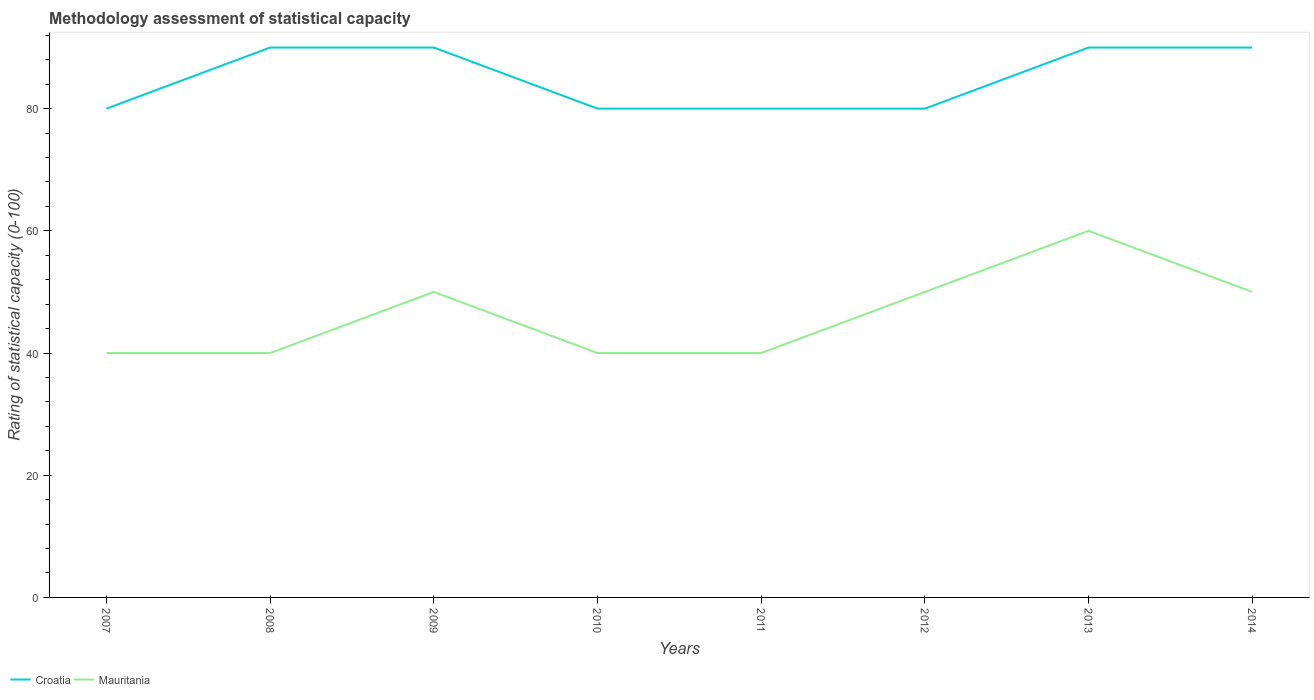Does the line corresponding to Mauritania intersect with the line corresponding to Croatia?
Make the answer very short. No. Is the number of lines equal to the number of legend labels?
Offer a very short reply. Yes. Across all years, what is the maximum rating of statistical capacity in Croatia?
Ensure brevity in your answer.  80. What is the total rating of statistical capacity in Mauritania in the graph?
Make the answer very short. -10. What is the difference between the highest and the second highest rating of statistical capacity in Croatia?
Provide a short and direct response. 10. How many lines are there?
Your answer should be compact. 2. What is the difference between two consecutive major ticks on the Y-axis?
Offer a very short reply. 20. Does the graph contain grids?
Offer a terse response. No. Where does the legend appear in the graph?
Your response must be concise. Bottom left. What is the title of the graph?
Provide a succinct answer. Methodology assessment of statistical capacity. Does "Belgium" appear as one of the legend labels in the graph?
Offer a terse response. No. What is the label or title of the Y-axis?
Your answer should be compact. Rating of statistical capacity (0-100). What is the Rating of statistical capacity (0-100) of Croatia in 2007?
Offer a very short reply. 80. What is the Rating of statistical capacity (0-100) of Mauritania in 2007?
Offer a terse response. 40. What is the Rating of statistical capacity (0-100) of Mauritania in 2008?
Offer a terse response. 40. What is the Rating of statistical capacity (0-100) in Mauritania in 2009?
Your answer should be compact. 50. What is the Rating of statistical capacity (0-100) in Croatia in 2010?
Give a very brief answer. 80. What is the Rating of statistical capacity (0-100) of Mauritania in 2010?
Make the answer very short. 40. What is the Rating of statistical capacity (0-100) of Croatia in 2011?
Provide a succinct answer. 80. What is the Rating of statistical capacity (0-100) of Mauritania in 2013?
Offer a very short reply. 60. What is the Rating of statistical capacity (0-100) in Croatia in 2014?
Ensure brevity in your answer.  90. Across all years, what is the maximum Rating of statistical capacity (0-100) in Croatia?
Offer a very short reply. 90. Across all years, what is the minimum Rating of statistical capacity (0-100) in Croatia?
Provide a succinct answer. 80. Across all years, what is the minimum Rating of statistical capacity (0-100) in Mauritania?
Provide a succinct answer. 40. What is the total Rating of statistical capacity (0-100) in Croatia in the graph?
Offer a terse response. 680. What is the total Rating of statistical capacity (0-100) of Mauritania in the graph?
Your answer should be very brief. 370. What is the difference between the Rating of statistical capacity (0-100) of Mauritania in 2007 and that in 2008?
Give a very brief answer. 0. What is the difference between the Rating of statistical capacity (0-100) of Croatia in 2007 and that in 2010?
Provide a short and direct response. 0. What is the difference between the Rating of statistical capacity (0-100) of Mauritania in 2007 and that in 2010?
Provide a short and direct response. 0. What is the difference between the Rating of statistical capacity (0-100) in Croatia in 2007 and that in 2011?
Offer a terse response. 0. What is the difference between the Rating of statistical capacity (0-100) in Croatia in 2007 and that in 2014?
Your response must be concise. -10. What is the difference between the Rating of statistical capacity (0-100) in Mauritania in 2007 and that in 2014?
Your answer should be compact. -10. What is the difference between the Rating of statistical capacity (0-100) of Croatia in 2008 and that in 2009?
Ensure brevity in your answer.  0. What is the difference between the Rating of statistical capacity (0-100) in Mauritania in 2008 and that in 2009?
Provide a succinct answer. -10. What is the difference between the Rating of statistical capacity (0-100) in Croatia in 2008 and that in 2010?
Offer a very short reply. 10. What is the difference between the Rating of statistical capacity (0-100) in Croatia in 2008 and that in 2011?
Provide a short and direct response. 10. What is the difference between the Rating of statistical capacity (0-100) in Croatia in 2009 and that in 2010?
Your response must be concise. 10. What is the difference between the Rating of statistical capacity (0-100) of Mauritania in 2009 and that in 2010?
Offer a very short reply. 10. What is the difference between the Rating of statistical capacity (0-100) of Mauritania in 2009 and that in 2011?
Provide a succinct answer. 10. What is the difference between the Rating of statistical capacity (0-100) in Croatia in 2009 and that in 2012?
Give a very brief answer. 10. What is the difference between the Rating of statistical capacity (0-100) in Mauritania in 2009 and that in 2012?
Your response must be concise. 0. What is the difference between the Rating of statistical capacity (0-100) of Mauritania in 2009 and that in 2013?
Your response must be concise. -10. What is the difference between the Rating of statistical capacity (0-100) of Croatia in 2009 and that in 2014?
Offer a terse response. 0. What is the difference between the Rating of statistical capacity (0-100) of Croatia in 2010 and that in 2011?
Provide a succinct answer. 0. What is the difference between the Rating of statistical capacity (0-100) of Croatia in 2010 and that in 2012?
Your answer should be compact. 0. What is the difference between the Rating of statistical capacity (0-100) in Mauritania in 2010 and that in 2012?
Offer a terse response. -10. What is the difference between the Rating of statistical capacity (0-100) of Croatia in 2010 and that in 2013?
Provide a short and direct response. -10. What is the difference between the Rating of statistical capacity (0-100) of Mauritania in 2010 and that in 2014?
Your answer should be compact. -10. What is the difference between the Rating of statistical capacity (0-100) of Mauritania in 2011 and that in 2012?
Give a very brief answer. -10. What is the difference between the Rating of statistical capacity (0-100) of Croatia in 2011 and that in 2013?
Your response must be concise. -10. What is the difference between the Rating of statistical capacity (0-100) of Croatia in 2011 and that in 2014?
Offer a terse response. -10. What is the difference between the Rating of statistical capacity (0-100) of Mauritania in 2011 and that in 2014?
Offer a very short reply. -10. What is the difference between the Rating of statistical capacity (0-100) in Croatia in 2012 and that in 2013?
Give a very brief answer. -10. What is the difference between the Rating of statistical capacity (0-100) in Mauritania in 2013 and that in 2014?
Your answer should be very brief. 10. What is the difference between the Rating of statistical capacity (0-100) in Croatia in 2007 and the Rating of statistical capacity (0-100) in Mauritania in 2009?
Your answer should be very brief. 30. What is the difference between the Rating of statistical capacity (0-100) of Croatia in 2007 and the Rating of statistical capacity (0-100) of Mauritania in 2010?
Make the answer very short. 40. What is the difference between the Rating of statistical capacity (0-100) of Croatia in 2008 and the Rating of statistical capacity (0-100) of Mauritania in 2010?
Give a very brief answer. 50. What is the difference between the Rating of statistical capacity (0-100) in Croatia in 2008 and the Rating of statistical capacity (0-100) in Mauritania in 2011?
Offer a very short reply. 50. What is the difference between the Rating of statistical capacity (0-100) in Croatia in 2008 and the Rating of statistical capacity (0-100) in Mauritania in 2013?
Make the answer very short. 30. What is the difference between the Rating of statistical capacity (0-100) in Croatia in 2009 and the Rating of statistical capacity (0-100) in Mauritania in 2014?
Give a very brief answer. 40. What is the difference between the Rating of statistical capacity (0-100) of Croatia in 2010 and the Rating of statistical capacity (0-100) of Mauritania in 2011?
Offer a terse response. 40. What is the difference between the Rating of statistical capacity (0-100) of Croatia in 2011 and the Rating of statistical capacity (0-100) of Mauritania in 2014?
Keep it short and to the point. 30. What is the average Rating of statistical capacity (0-100) in Mauritania per year?
Offer a very short reply. 46.25. In the year 2007, what is the difference between the Rating of statistical capacity (0-100) in Croatia and Rating of statistical capacity (0-100) in Mauritania?
Make the answer very short. 40. In the year 2008, what is the difference between the Rating of statistical capacity (0-100) in Croatia and Rating of statistical capacity (0-100) in Mauritania?
Provide a short and direct response. 50. In the year 2010, what is the difference between the Rating of statistical capacity (0-100) in Croatia and Rating of statistical capacity (0-100) in Mauritania?
Your response must be concise. 40. In the year 2011, what is the difference between the Rating of statistical capacity (0-100) in Croatia and Rating of statistical capacity (0-100) in Mauritania?
Offer a terse response. 40. In the year 2012, what is the difference between the Rating of statistical capacity (0-100) in Croatia and Rating of statistical capacity (0-100) in Mauritania?
Provide a short and direct response. 30. In the year 2013, what is the difference between the Rating of statistical capacity (0-100) of Croatia and Rating of statistical capacity (0-100) of Mauritania?
Offer a very short reply. 30. In the year 2014, what is the difference between the Rating of statistical capacity (0-100) of Croatia and Rating of statistical capacity (0-100) of Mauritania?
Your answer should be compact. 40. What is the ratio of the Rating of statistical capacity (0-100) of Croatia in 2007 to that in 2008?
Make the answer very short. 0.89. What is the ratio of the Rating of statistical capacity (0-100) of Mauritania in 2007 to that in 2008?
Your answer should be very brief. 1. What is the ratio of the Rating of statistical capacity (0-100) in Croatia in 2007 to that in 2009?
Your answer should be compact. 0.89. What is the ratio of the Rating of statistical capacity (0-100) in Croatia in 2007 to that in 2010?
Keep it short and to the point. 1. What is the ratio of the Rating of statistical capacity (0-100) of Croatia in 2007 to that in 2011?
Make the answer very short. 1. What is the ratio of the Rating of statistical capacity (0-100) in Croatia in 2007 to that in 2012?
Offer a terse response. 1. What is the ratio of the Rating of statistical capacity (0-100) in Mauritania in 2007 to that in 2012?
Your answer should be compact. 0.8. What is the ratio of the Rating of statistical capacity (0-100) in Croatia in 2007 to that in 2013?
Ensure brevity in your answer.  0.89. What is the ratio of the Rating of statistical capacity (0-100) of Mauritania in 2007 to that in 2013?
Your answer should be very brief. 0.67. What is the ratio of the Rating of statistical capacity (0-100) in Croatia in 2008 to that in 2009?
Provide a succinct answer. 1. What is the ratio of the Rating of statistical capacity (0-100) of Croatia in 2008 to that in 2011?
Provide a short and direct response. 1.12. What is the ratio of the Rating of statistical capacity (0-100) in Croatia in 2008 to that in 2014?
Give a very brief answer. 1. What is the ratio of the Rating of statistical capacity (0-100) of Croatia in 2009 to that in 2010?
Your response must be concise. 1.12. What is the ratio of the Rating of statistical capacity (0-100) of Mauritania in 2009 to that in 2010?
Provide a succinct answer. 1.25. What is the ratio of the Rating of statistical capacity (0-100) of Croatia in 2009 to that in 2011?
Your answer should be very brief. 1.12. What is the ratio of the Rating of statistical capacity (0-100) in Mauritania in 2009 to that in 2011?
Provide a short and direct response. 1.25. What is the ratio of the Rating of statistical capacity (0-100) of Croatia in 2009 to that in 2012?
Ensure brevity in your answer.  1.12. What is the ratio of the Rating of statistical capacity (0-100) in Mauritania in 2009 to that in 2012?
Provide a short and direct response. 1. What is the ratio of the Rating of statistical capacity (0-100) of Mauritania in 2009 to that in 2013?
Your response must be concise. 0.83. What is the ratio of the Rating of statistical capacity (0-100) in Mauritania in 2010 to that in 2011?
Ensure brevity in your answer.  1. What is the ratio of the Rating of statistical capacity (0-100) of Croatia in 2010 to that in 2012?
Your answer should be compact. 1. What is the ratio of the Rating of statistical capacity (0-100) of Mauritania in 2010 to that in 2012?
Your answer should be very brief. 0.8. What is the ratio of the Rating of statistical capacity (0-100) in Mauritania in 2010 to that in 2013?
Provide a short and direct response. 0.67. What is the ratio of the Rating of statistical capacity (0-100) in Croatia in 2011 to that in 2012?
Your response must be concise. 1. What is the ratio of the Rating of statistical capacity (0-100) of Mauritania in 2011 to that in 2014?
Make the answer very short. 0.8. What is the ratio of the Rating of statistical capacity (0-100) in Mauritania in 2012 to that in 2013?
Your answer should be compact. 0.83. What is the ratio of the Rating of statistical capacity (0-100) of Croatia in 2012 to that in 2014?
Make the answer very short. 0.89. What is the ratio of the Rating of statistical capacity (0-100) of Mauritania in 2012 to that in 2014?
Offer a terse response. 1. What is the difference between the highest and the lowest Rating of statistical capacity (0-100) of Mauritania?
Ensure brevity in your answer.  20. 